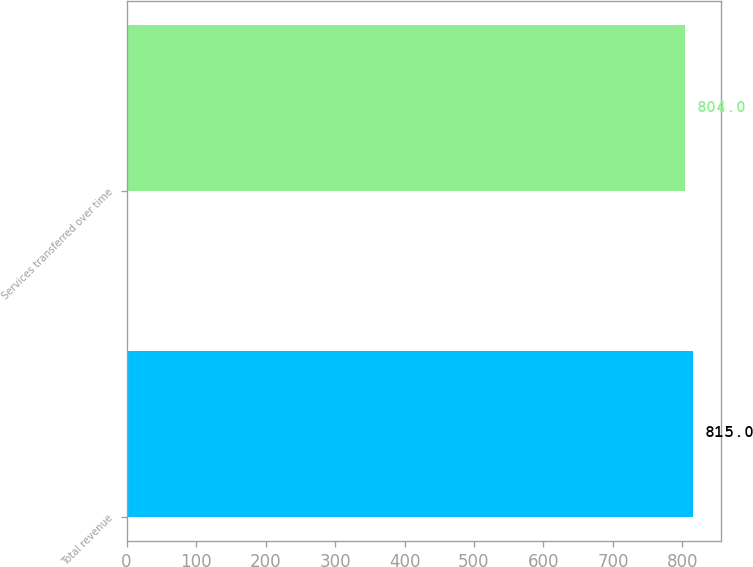Convert chart. <chart><loc_0><loc_0><loc_500><loc_500><bar_chart><fcel>Total revenue<fcel>Services transferred over time<nl><fcel>815<fcel>804<nl></chart> 